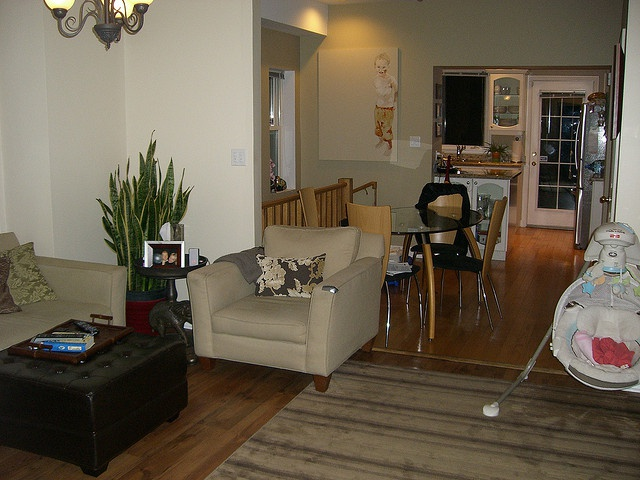Describe the objects in this image and their specific colors. I can see chair in gray and black tones, chair in gray, darkgreen, and black tones, couch in gray, darkgreen, and black tones, potted plant in gray, black, darkgreen, and darkgray tones, and refrigerator in gray, black, darkgray, and lightgray tones in this image. 